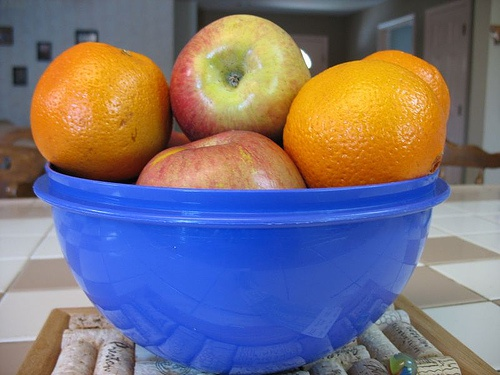Describe the objects in this image and their specific colors. I can see bowl in darkblue and blue tones, orange in darkblue, orange, and red tones, orange in darkblue, orange, olive, and maroon tones, apple in darkblue, khaki, and tan tones, and apple in darkblue, tan, and salmon tones in this image. 